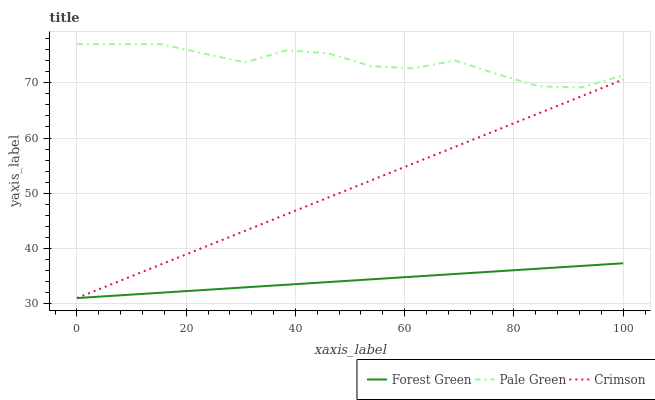Does Forest Green have the minimum area under the curve?
Answer yes or no. Yes. Does Pale Green have the maximum area under the curve?
Answer yes or no. Yes. Does Pale Green have the minimum area under the curve?
Answer yes or no. No. Does Forest Green have the maximum area under the curve?
Answer yes or no. No. Is Forest Green the smoothest?
Answer yes or no. Yes. Is Pale Green the roughest?
Answer yes or no. Yes. Is Pale Green the smoothest?
Answer yes or no. No. Is Forest Green the roughest?
Answer yes or no. No. Does Crimson have the lowest value?
Answer yes or no. Yes. Does Pale Green have the lowest value?
Answer yes or no. No. Does Pale Green have the highest value?
Answer yes or no. Yes. Does Forest Green have the highest value?
Answer yes or no. No. Is Forest Green less than Pale Green?
Answer yes or no. Yes. Is Pale Green greater than Forest Green?
Answer yes or no. Yes. Does Forest Green intersect Crimson?
Answer yes or no. Yes. Is Forest Green less than Crimson?
Answer yes or no. No. Is Forest Green greater than Crimson?
Answer yes or no. No. Does Forest Green intersect Pale Green?
Answer yes or no. No. 